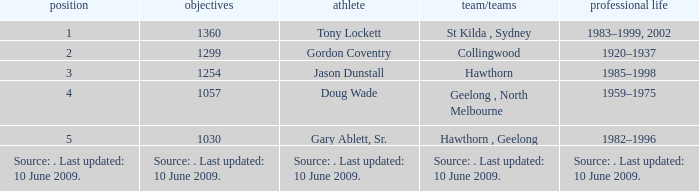What is the rank of player Jason Dunstall? 3.0. 